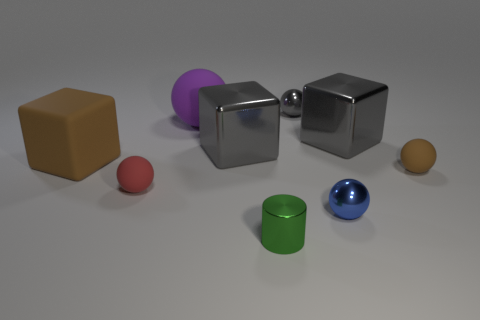The object that is the same color as the large rubber cube is what size?
Offer a terse response. Small. How many gray things are either large rubber blocks or big metallic cylinders?
Provide a succinct answer. 0. What is the shape of the tiny matte object to the left of the metallic ball in front of the large metal object that is to the right of the tiny green metal cylinder?
Provide a short and direct response. Sphere. There is a matte thing that is the same size as the red ball; what color is it?
Your answer should be compact. Brown. How many small green things have the same shape as the small brown rubber object?
Your answer should be very brief. 0. There is a red thing; is its size the same as the matte ball that is to the right of the small green cylinder?
Your answer should be compact. Yes. The small matte object behind the small rubber ball that is left of the large purple object is what shape?
Provide a short and direct response. Sphere. Are there fewer small balls on the right side of the gray ball than tiny blue metallic cubes?
Offer a very short reply. No. There is a small object that is the same color as the rubber cube; what shape is it?
Offer a very short reply. Sphere. What number of red shiny things are the same size as the gray ball?
Provide a succinct answer. 0. 